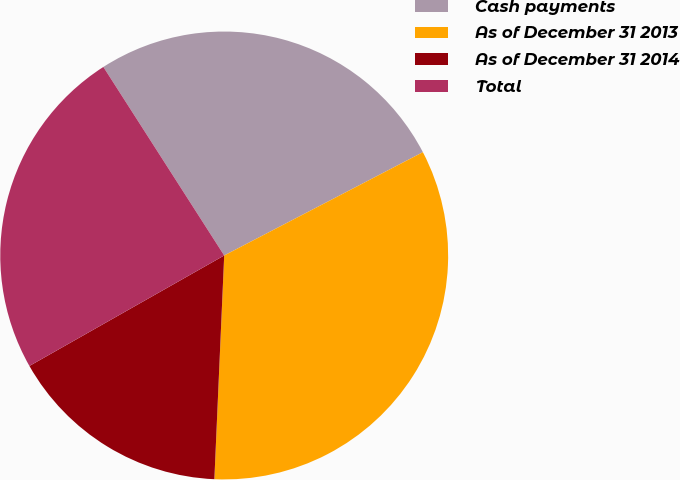Convert chart. <chart><loc_0><loc_0><loc_500><loc_500><pie_chart><fcel>Cash payments<fcel>As of December 31 2013<fcel>As of December 31 2014<fcel>Total<nl><fcel>26.44%<fcel>33.33%<fcel>16.09%<fcel>24.14%<nl></chart> 